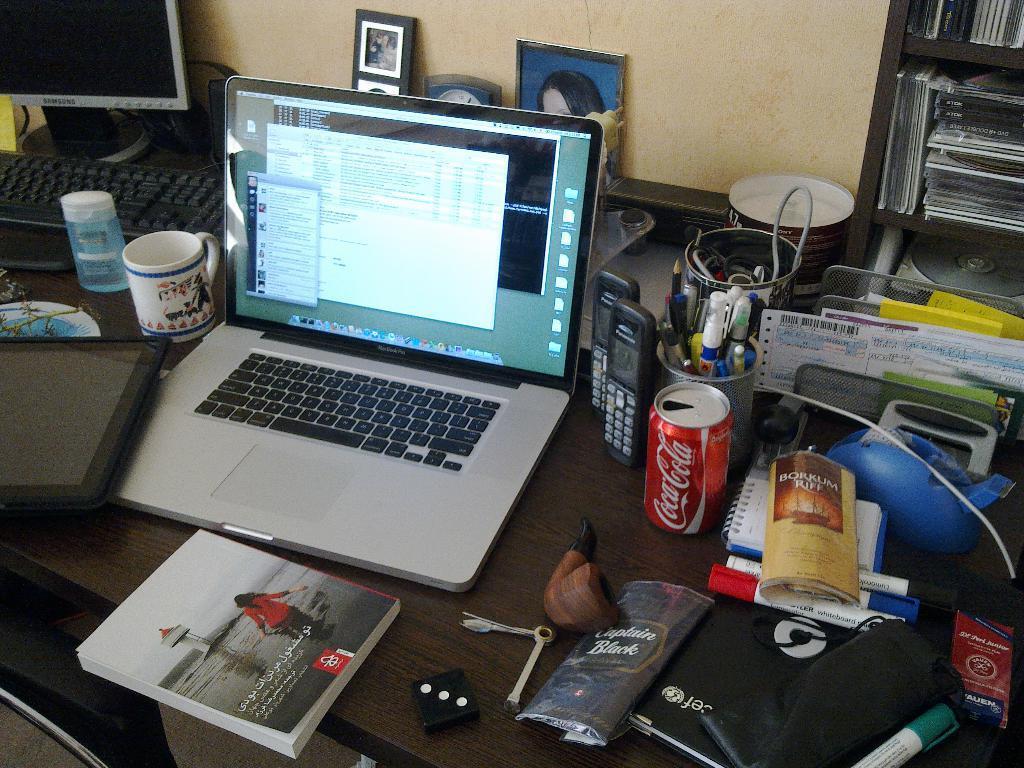In one or two sentences, can you explain what this image depicts? In this image I can see a laptop,system and some of the objects on the table. To the right there is a cupboard of books. 